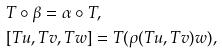<formula> <loc_0><loc_0><loc_500><loc_500>& T \circ \beta = \alpha \circ T , \\ & [ T u , T v , T w ] = T ( \rho ( T u , T v ) w ) ,</formula> 